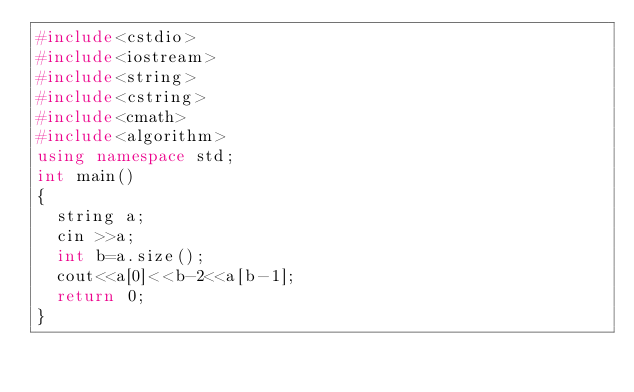<code> <loc_0><loc_0><loc_500><loc_500><_C++_>#include<cstdio>
#include<iostream>
#include<string>
#include<cstring>
#include<cmath>
#include<algorithm>
using namespace std;
int main()
{
	string a;
	cin >>a;
	int b=a.size();
	cout<<a[0]<<b-2<<a[b-1];
	return 0;
}</code> 